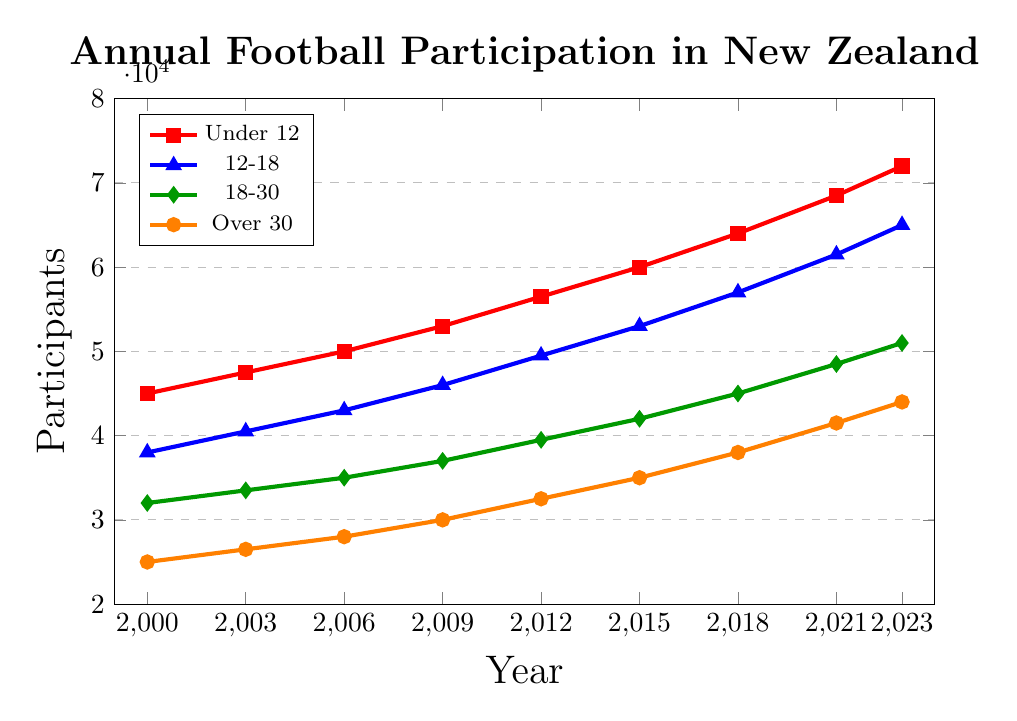What is the participation rate for the 18-30 age group in 2021? To find this, refer to the green line representing the 18-30 age group and look at the participation rate in 2021.
Answer: 48500 Which age group had the highest increase in participation from 2000 to 2023? Calculate the increase for each age group by subtracting the 2000 value from the 2023 value. The red line (Under 12) shows the highest increase from 45000 to 72000, which is 27000.
Answer: Under 12 Between which consecutive years did the Under 12 age group see the highest increase in participation? Check the red line and compare the differences between the consecutive years. 2021 to 2023 shows the largest increase: 72000 - 68500 = 3500.
Answer: 2021 to 2023 What is the difference in participation rates between the Under 12 and Over 30 age groups in 2023? Subtract the value for the Over 30 group (orange line) from the Under 12 group (red line) in 2023: 72000 - 44000 = 28000.
Answer: 28000 What is the average participation rate for the 12-18 age group over all the years shown? Sum the participation rates for the blue line at each year and divide by the number of years: (38000 + 40500 + 43000 + 46000 + 49500 + 53000 + 57000 + 61500 + 65000) / 9 = 50411.1.
Answer: 50411.1 Which year did the Over 30 age group cross the 30000 participant markup? Look at the orange line and find the year where the value surpasses 30000 for the first time. This happened in 2009.
Answer: 2009 How much did participation rates increase for the 12-18 age group between 2006 and 2015? Subtract the 2006 value from the 2015 value for the blue line: 53000 - 43000 = 10000.
Answer: 10000 In which year did the 18-30 age group reach the same level of participation as the Under 12 age group in 2000? Find the value for the Under 12 group in 2000 (45000) and match it to a year for the 18-30 group (green line). This happened in 2021.
Answer: 2021 Between which years did the Over 30 age group experience the smallest increase in participation? Calculate the differences between consecutive years for the orange line and identify the smallest difference. 2000 to 2003 had a 1500 increase.
Answer: 2000 to 2003 